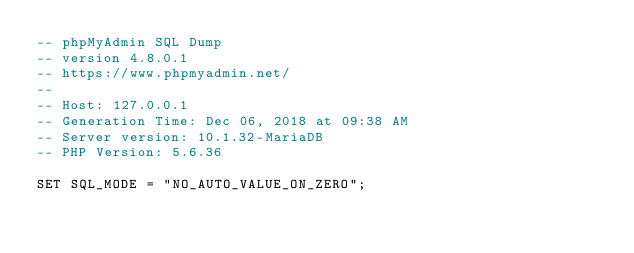<code> <loc_0><loc_0><loc_500><loc_500><_SQL_>-- phpMyAdmin SQL Dump
-- version 4.8.0.1
-- https://www.phpmyadmin.net/
--
-- Host: 127.0.0.1
-- Generation Time: Dec 06, 2018 at 09:38 AM
-- Server version: 10.1.32-MariaDB
-- PHP Version: 5.6.36

SET SQL_MODE = "NO_AUTO_VALUE_ON_ZERO";</code> 